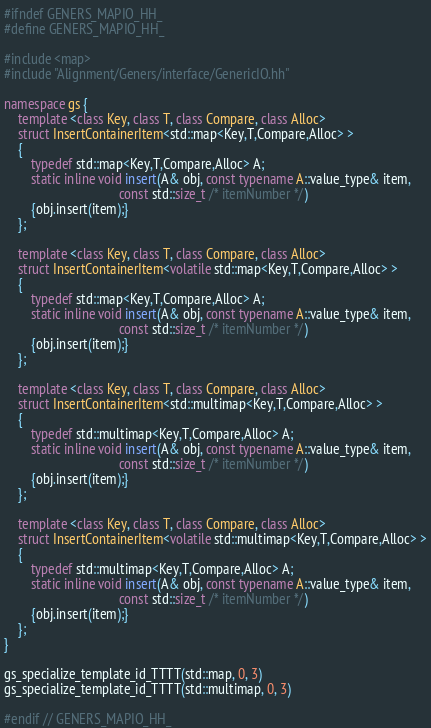<code> <loc_0><loc_0><loc_500><loc_500><_C++_>#ifndef GENERS_MAPIO_HH_
#define GENERS_MAPIO_HH_

#include <map>
#include "Alignment/Geners/interface/GenericIO.hh"

namespace gs {
    template <class Key, class T, class Compare, class Alloc>
    struct InsertContainerItem<std::map<Key,T,Compare,Alloc> >
    {
        typedef std::map<Key,T,Compare,Alloc> A;
        static inline void insert(A& obj, const typename A::value_type& item,
                                  const std::size_t /* itemNumber */)
        {obj.insert(item);}
    };

    template <class Key, class T, class Compare, class Alloc>
    struct InsertContainerItem<volatile std::map<Key,T,Compare,Alloc> >
    {
        typedef std::map<Key,T,Compare,Alloc> A;
        static inline void insert(A& obj, const typename A::value_type& item,
                                  const std::size_t /* itemNumber */)
        {obj.insert(item);}
    };

    template <class Key, class T, class Compare, class Alloc>
    struct InsertContainerItem<std::multimap<Key,T,Compare,Alloc> >
    {
        typedef std::multimap<Key,T,Compare,Alloc> A;
        static inline void insert(A& obj, const typename A::value_type& item,
                                  const std::size_t /* itemNumber */)
        {obj.insert(item);}
    };

    template <class Key, class T, class Compare, class Alloc>
    struct InsertContainerItem<volatile std::multimap<Key,T,Compare,Alloc> >
    {
        typedef std::multimap<Key,T,Compare,Alloc> A;
        static inline void insert(A& obj, const typename A::value_type& item,
                                  const std::size_t /* itemNumber */)
        {obj.insert(item);}
    };
}

gs_specialize_template_id_TTTT(std::map, 0, 3)
gs_specialize_template_id_TTTT(std::multimap, 0, 3)

#endif // GENERS_MAPIO_HH_

</code> 